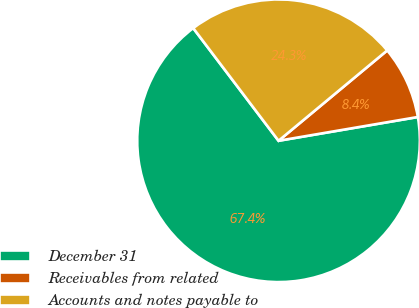Convert chart. <chart><loc_0><loc_0><loc_500><loc_500><pie_chart><fcel>December 31<fcel>Receivables from related<fcel>Accounts and notes payable to<nl><fcel>67.37%<fcel>8.35%<fcel>24.28%<nl></chart> 